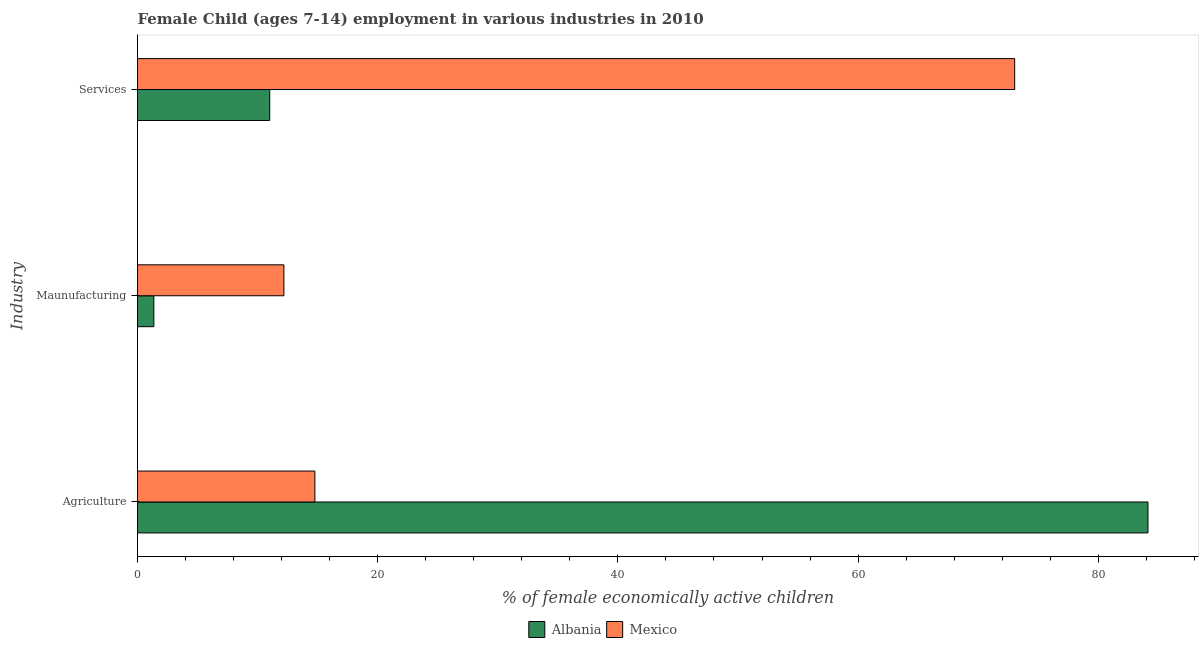How many different coloured bars are there?
Keep it short and to the point. 2. Are the number of bars per tick equal to the number of legend labels?
Your answer should be compact. Yes. Are the number of bars on each tick of the Y-axis equal?
Your response must be concise. Yes. What is the label of the 2nd group of bars from the top?
Your answer should be compact. Maunufacturing. What is the percentage of economically active children in manufacturing in Albania?
Make the answer very short. 1.36. Across all countries, what is the maximum percentage of economically active children in services?
Ensure brevity in your answer.  73.04. Across all countries, what is the minimum percentage of economically active children in agriculture?
Give a very brief answer. 14.77. In which country was the percentage of economically active children in services maximum?
Provide a short and direct response. Mexico. In which country was the percentage of economically active children in agriculture minimum?
Give a very brief answer. Mexico. What is the total percentage of economically active children in services in the graph?
Make the answer very short. 84.05. What is the difference between the percentage of economically active children in agriculture in Albania and that in Mexico?
Your response must be concise. 69.37. What is the difference between the percentage of economically active children in manufacturing in Albania and the percentage of economically active children in agriculture in Mexico?
Make the answer very short. -13.41. What is the average percentage of economically active children in agriculture per country?
Your answer should be very brief. 49.45. What is the difference between the percentage of economically active children in services and percentage of economically active children in agriculture in Albania?
Your answer should be compact. -73.13. In how many countries, is the percentage of economically active children in agriculture greater than 72 %?
Offer a very short reply. 1. What is the ratio of the percentage of economically active children in manufacturing in Mexico to that in Albania?
Provide a succinct answer. 8.96. What is the difference between the highest and the second highest percentage of economically active children in services?
Provide a short and direct response. 62.03. What is the difference between the highest and the lowest percentage of economically active children in agriculture?
Ensure brevity in your answer.  69.37. What does the 2nd bar from the top in Maunufacturing represents?
Your answer should be compact. Albania. What does the 1st bar from the bottom in Agriculture represents?
Your answer should be compact. Albania. How many bars are there?
Your answer should be compact. 6. Are all the bars in the graph horizontal?
Offer a very short reply. Yes. How many countries are there in the graph?
Offer a terse response. 2. What is the difference between two consecutive major ticks on the X-axis?
Keep it short and to the point. 20. Are the values on the major ticks of X-axis written in scientific E-notation?
Your answer should be compact. No. Does the graph contain any zero values?
Make the answer very short. No. How are the legend labels stacked?
Keep it short and to the point. Horizontal. What is the title of the graph?
Your answer should be compact. Female Child (ages 7-14) employment in various industries in 2010. What is the label or title of the X-axis?
Your response must be concise. % of female economically active children. What is the label or title of the Y-axis?
Give a very brief answer. Industry. What is the % of female economically active children of Albania in Agriculture?
Your response must be concise. 84.14. What is the % of female economically active children in Mexico in Agriculture?
Provide a short and direct response. 14.77. What is the % of female economically active children of Albania in Maunufacturing?
Your response must be concise. 1.36. What is the % of female economically active children of Mexico in Maunufacturing?
Ensure brevity in your answer.  12.19. What is the % of female economically active children in Albania in Services?
Keep it short and to the point. 11.01. What is the % of female economically active children in Mexico in Services?
Your answer should be compact. 73.04. Across all Industry, what is the maximum % of female economically active children of Albania?
Your answer should be very brief. 84.14. Across all Industry, what is the maximum % of female economically active children of Mexico?
Provide a succinct answer. 73.04. Across all Industry, what is the minimum % of female economically active children of Albania?
Offer a very short reply. 1.36. Across all Industry, what is the minimum % of female economically active children of Mexico?
Offer a very short reply. 12.19. What is the total % of female economically active children in Albania in the graph?
Your response must be concise. 96.51. What is the total % of female economically active children in Mexico in the graph?
Give a very brief answer. 100. What is the difference between the % of female economically active children in Albania in Agriculture and that in Maunufacturing?
Make the answer very short. 82.78. What is the difference between the % of female economically active children in Mexico in Agriculture and that in Maunufacturing?
Make the answer very short. 2.58. What is the difference between the % of female economically active children in Albania in Agriculture and that in Services?
Your response must be concise. 73.13. What is the difference between the % of female economically active children of Mexico in Agriculture and that in Services?
Give a very brief answer. -58.27. What is the difference between the % of female economically active children in Albania in Maunufacturing and that in Services?
Your response must be concise. -9.65. What is the difference between the % of female economically active children of Mexico in Maunufacturing and that in Services?
Your answer should be compact. -60.85. What is the difference between the % of female economically active children in Albania in Agriculture and the % of female economically active children in Mexico in Maunufacturing?
Your answer should be very brief. 71.95. What is the difference between the % of female economically active children of Albania in Maunufacturing and the % of female economically active children of Mexico in Services?
Your response must be concise. -71.68. What is the average % of female economically active children in Albania per Industry?
Offer a terse response. 32.17. What is the average % of female economically active children of Mexico per Industry?
Your answer should be compact. 33.33. What is the difference between the % of female economically active children in Albania and % of female economically active children in Mexico in Agriculture?
Your response must be concise. 69.37. What is the difference between the % of female economically active children in Albania and % of female economically active children in Mexico in Maunufacturing?
Give a very brief answer. -10.83. What is the difference between the % of female economically active children of Albania and % of female economically active children of Mexico in Services?
Offer a very short reply. -62.03. What is the ratio of the % of female economically active children of Albania in Agriculture to that in Maunufacturing?
Provide a short and direct response. 61.87. What is the ratio of the % of female economically active children of Mexico in Agriculture to that in Maunufacturing?
Give a very brief answer. 1.21. What is the ratio of the % of female economically active children of Albania in Agriculture to that in Services?
Make the answer very short. 7.64. What is the ratio of the % of female economically active children in Mexico in Agriculture to that in Services?
Keep it short and to the point. 0.2. What is the ratio of the % of female economically active children in Albania in Maunufacturing to that in Services?
Keep it short and to the point. 0.12. What is the ratio of the % of female economically active children of Mexico in Maunufacturing to that in Services?
Ensure brevity in your answer.  0.17. What is the difference between the highest and the second highest % of female economically active children in Albania?
Offer a very short reply. 73.13. What is the difference between the highest and the second highest % of female economically active children of Mexico?
Give a very brief answer. 58.27. What is the difference between the highest and the lowest % of female economically active children of Albania?
Your answer should be very brief. 82.78. What is the difference between the highest and the lowest % of female economically active children in Mexico?
Ensure brevity in your answer.  60.85. 